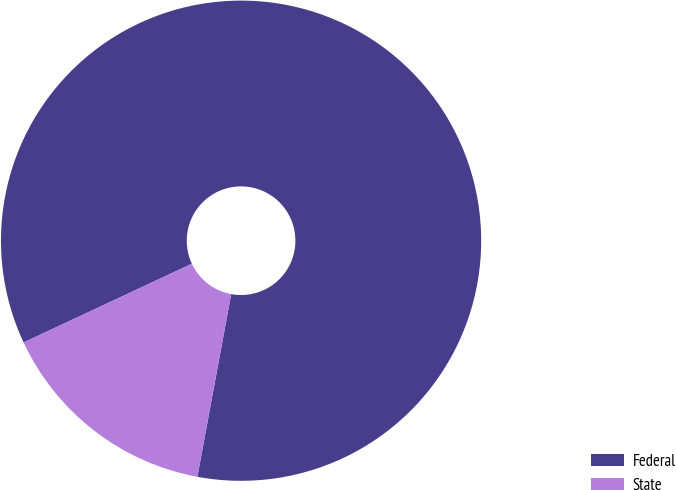<chart> <loc_0><loc_0><loc_500><loc_500><pie_chart><fcel>Federal<fcel>State<nl><fcel>84.88%<fcel>15.12%<nl></chart> 